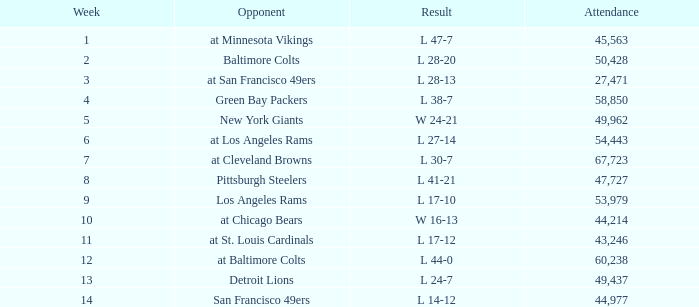Which Week has an Opponent of pittsburgh steelers, and an Attendance larger than 47,727? None. 